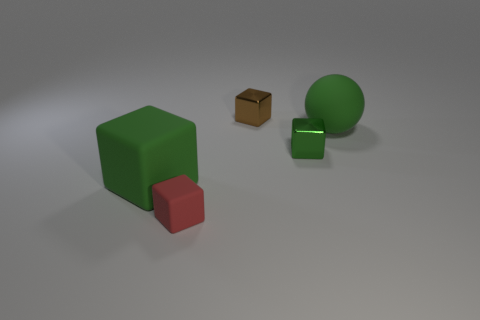Subtract all small cubes. How many cubes are left? 1 Add 4 big spheres. How many objects exist? 9 Subtract all green blocks. How many blocks are left? 2 Subtract all cubes. How many objects are left? 1 Add 4 tiny green cubes. How many tiny green cubes are left? 5 Add 1 tiny brown blocks. How many tiny brown blocks exist? 2 Subtract 1 green balls. How many objects are left? 4 Subtract all blue cubes. Subtract all brown cylinders. How many cubes are left? 4 Subtract all gray balls. How many green cubes are left? 2 Subtract all green rubber spheres. Subtract all rubber blocks. How many objects are left? 2 